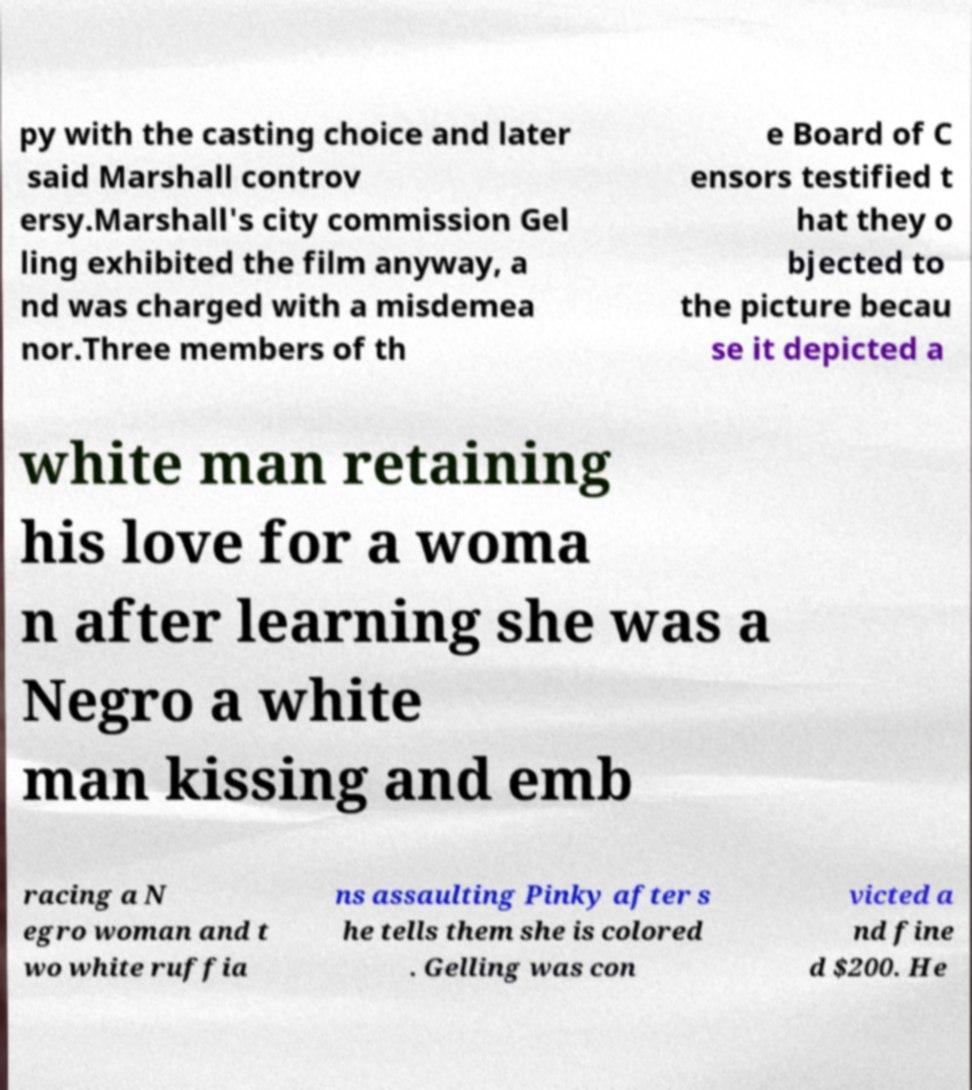Please read and relay the text visible in this image. What does it say? py with the casting choice and later said Marshall controv ersy.Marshall's city commission Gel ling exhibited the film anyway, a nd was charged with a misdemea nor.Three members of th e Board of C ensors testified t hat they o bjected to the picture becau se it depicted a white man retaining his love for a woma n after learning she was a Negro a white man kissing and emb racing a N egro woman and t wo white ruffia ns assaulting Pinky after s he tells them she is colored . Gelling was con victed a nd fine d $200. He 